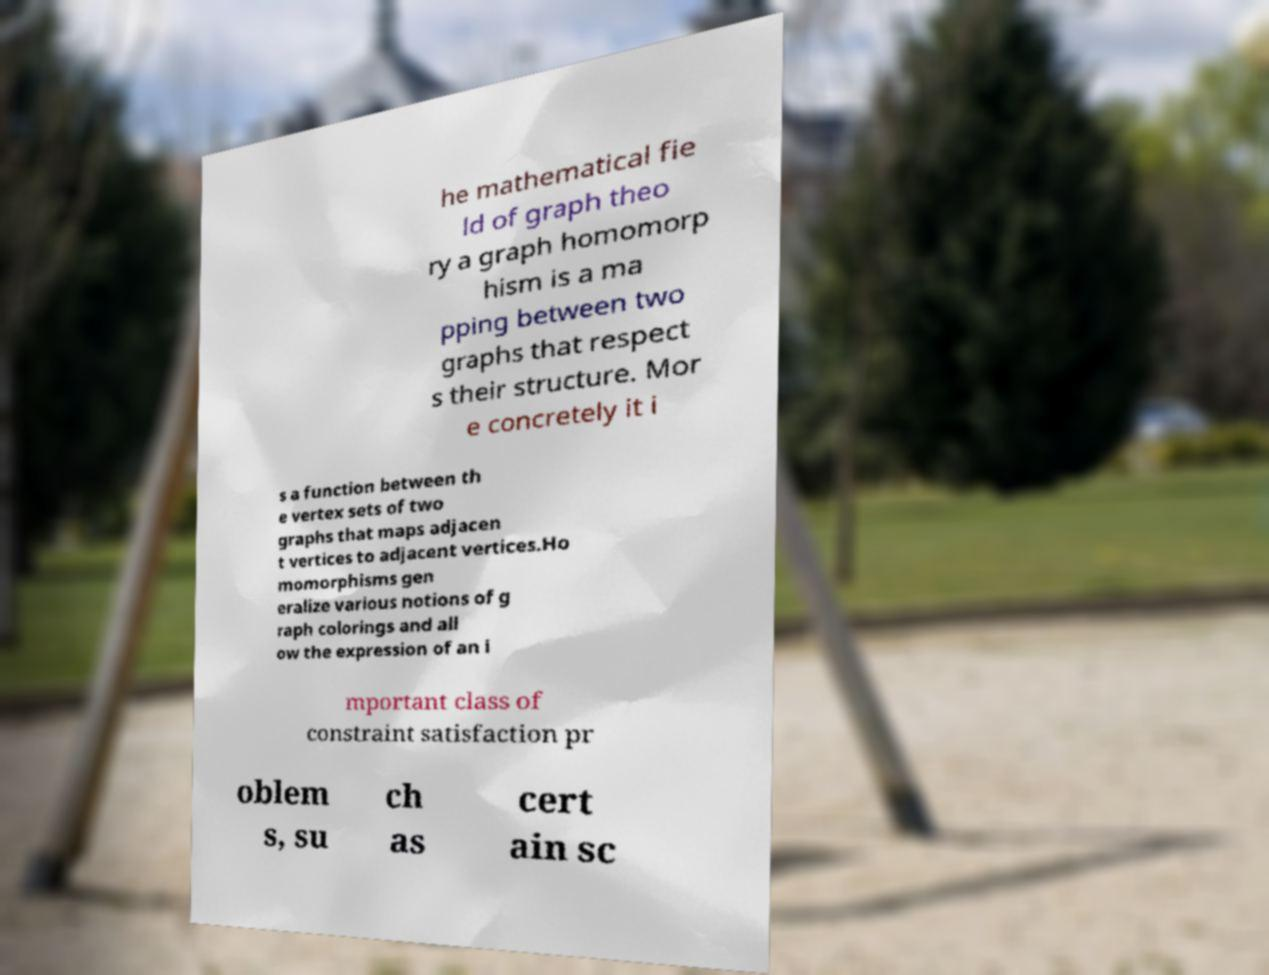Please read and relay the text visible in this image. What does it say? he mathematical fie ld of graph theo ry a graph homomorp hism is a ma pping between two graphs that respect s their structure. Mor e concretely it i s a function between th e vertex sets of two graphs that maps adjacen t vertices to adjacent vertices.Ho momorphisms gen eralize various notions of g raph colorings and all ow the expression of an i mportant class of constraint satisfaction pr oblem s, su ch as cert ain sc 